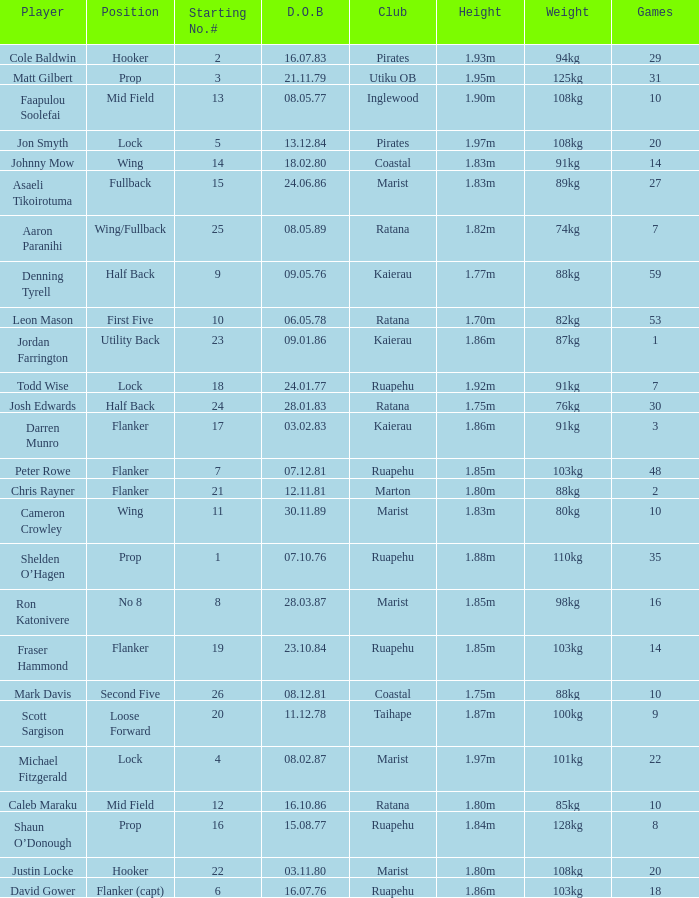How many games were played where the height of the player is 1.92m? 1.0. 